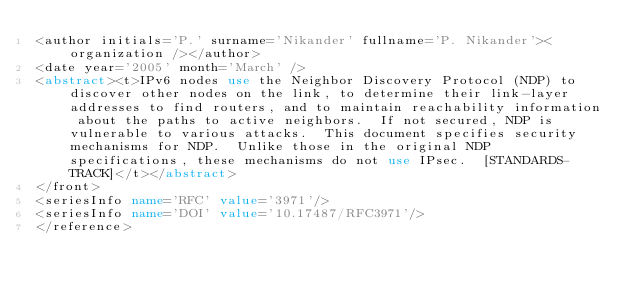<code> <loc_0><loc_0><loc_500><loc_500><_XML_><author initials='P.' surname='Nikander' fullname='P. Nikander'><organization /></author>
<date year='2005' month='March' />
<abstract><t>IPv6 nodes use the Neighbor Discovery Protocol (NDP) to discover other nodes on the link, to determine their link-layer addresses to find routers, and to maintain reachability information about the paths to active neighbors.  If not secured, NDP is vulnerable to various attacks.  This document specifies security mechanisms for NDP.  Unlike those in the original NDP specifications, these mechanisms do not use IPsec.  [STANDARDS-TRACK]</t></abstract>
</front>
<seriesInfo name='RFC' value='3971'/>
<seriesInfo name='DOI' value='10.17487/RFC3971'/>
</reference>
</code> 